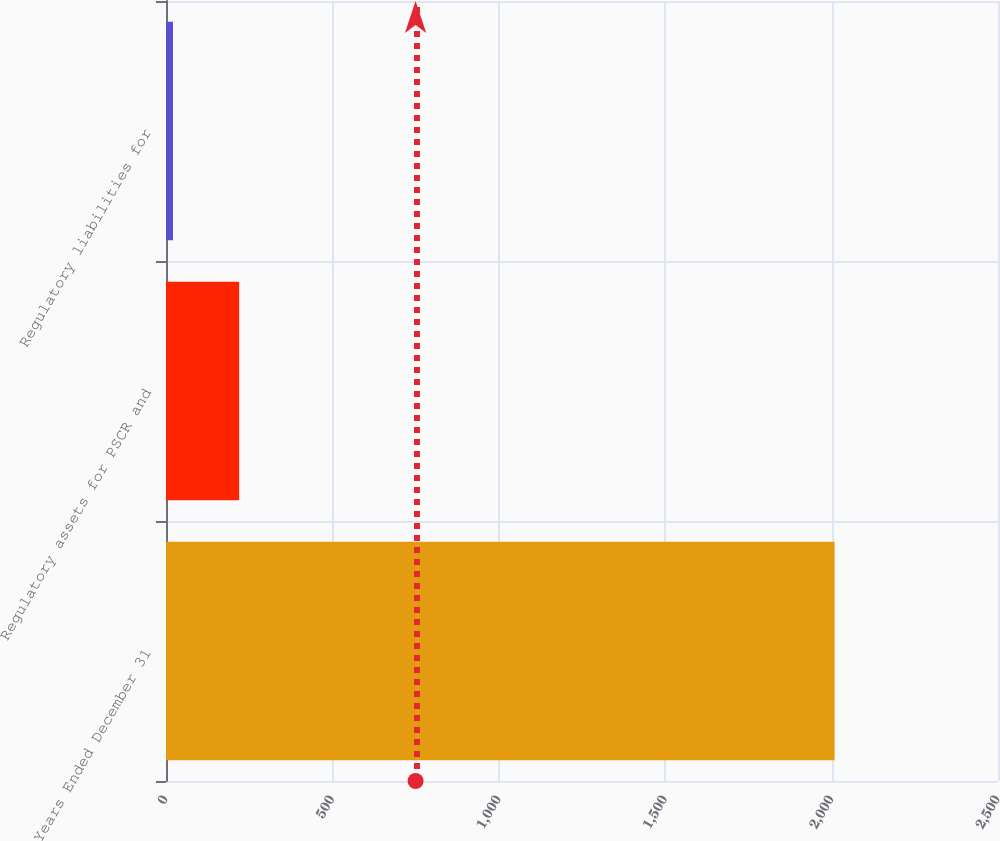<chart> <loc_0><loc_0><loc_500><loc_500><bar_chart><fcel>Years Ended December 31<fcel>Regulatory assets for PSCR and<fcel>Regulatory liabilities for<nl><fcel>2009<fcel>219.8<fcel>21<nl></chart> 